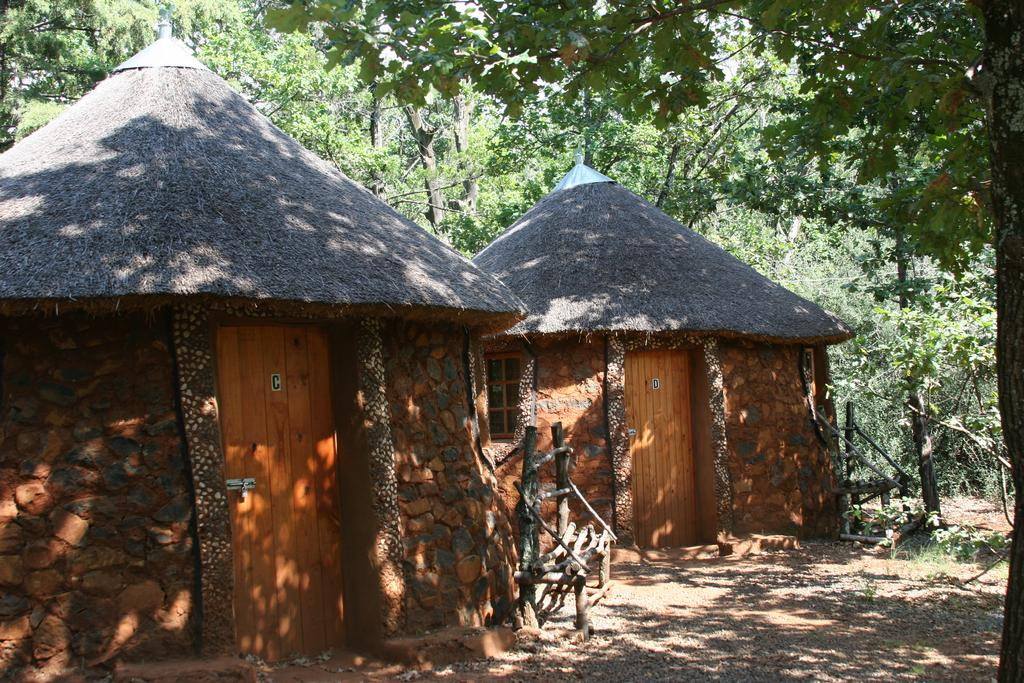What type of structures can be seen in the image? There are huts in the image. What natural elements are present in the image? There are trees in the image. Can you see a rabbit or an owl in the image? There is no rabbit or owl present in the image. Is there any indication of war or conflict in the image? There is no indication of war or conflict in the image; it features huts and trees. 